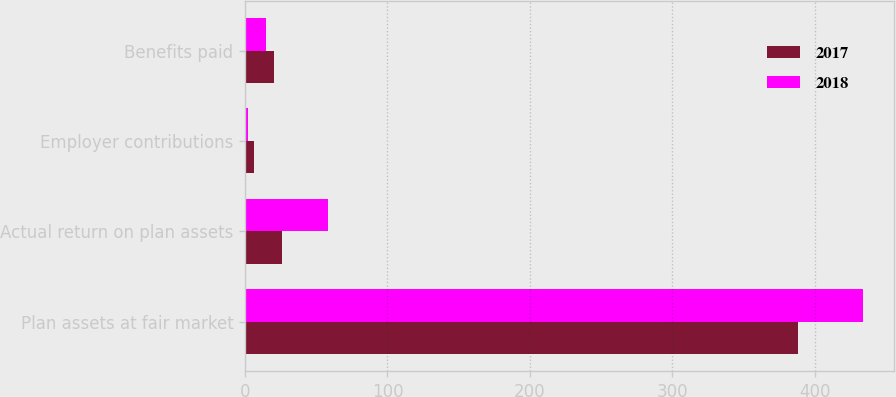Convert chart. <chart><loc_0><loc_0><loc_500><loc_500><stacked_bar_chart><ecel><fcel>Plan assets at fair market<fcel>Actual return on plan assets<fcel>Employer contributions<fcel>Benefits paid<nl><fcel>2017<fcel>388.5<fcel>25.7<fcel>6.4<fcel>20.3<nl><fcel>2018<fcel>433.6<fcel>58.2<fcel>1.8<fcel>14.9<nl></chart> 